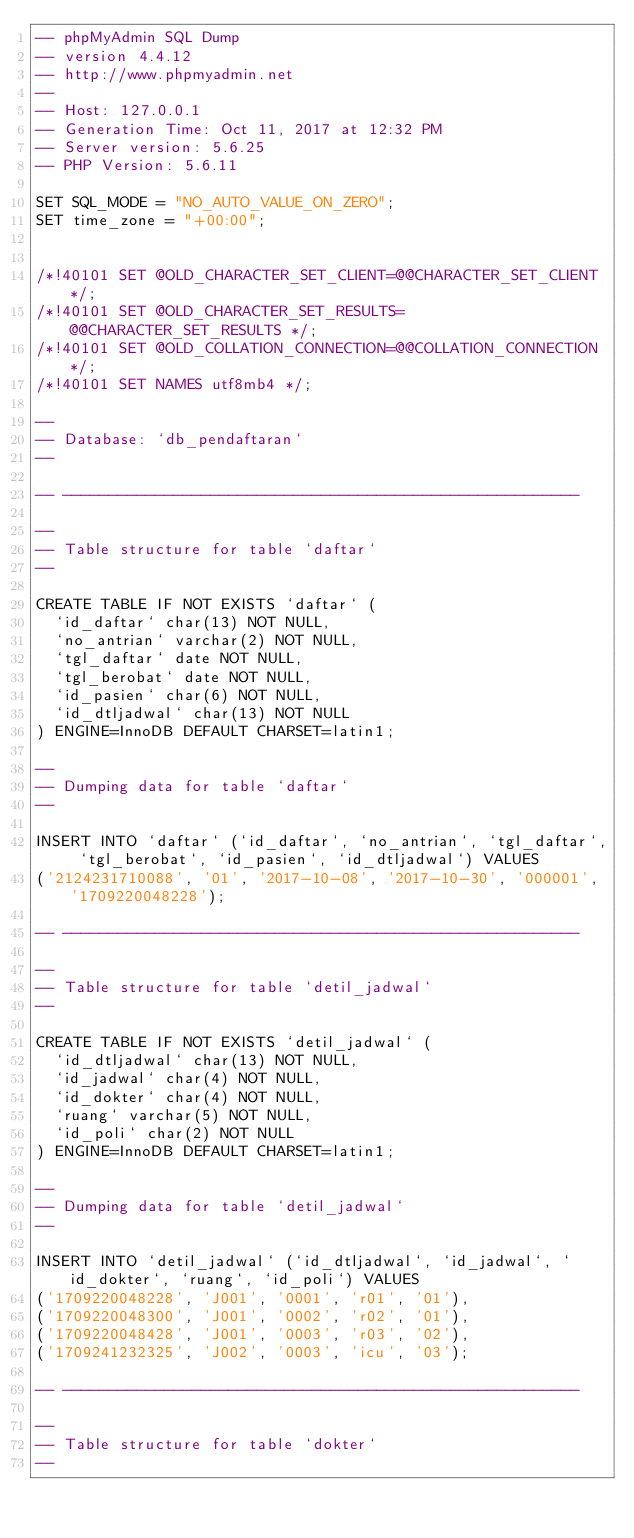<code> <loc_0><loc_0><loc_500><loc_500><_SQL_>-- phpMyAdmin SQL Dump
-- version 4.4.12
-- http://www.phpmyadmin.net
--
-- Host: 127.0.0.1
-- Generation Time: Oct 11, 2017 at 12:32 PM
-- Server version: 5.6.25
-- PHP Version: 5.6.11

SET SQL_MODE = "NO_AUTO_VALUE_ON_ZERO";
SET time_zone = "+00:00";


/*!40101 SET @OLD_CHARACTER_SET_CLIENT=@@CHARACTER_SET_CLIENT */;
/*!40101 SET @OLD_CHARACTER_SET_RESULTS=@@CHARACTER_SET_RESULTS */;
/*!40101 SET @OLD_COLLATION_CONNECTION=@@COLLATION_CONNECTION */;
/*!40101 SET NAMES utf8mb4 */;

--
-- Database: `db_pendaftaran`
--

-- --------------------------------------------------------

--
-- Table structure for table `daftar`
--

CREATE TABLE IF NOT EXISTS `daftar` (
  `id_daftar` char(13) NOT NULL,
  `no_antrian` varchar(2) NOT NULL,
  `tgl_daftar` date NOT NULL,
  `tgl_berobat` date NOT NULL,
  `id_pasien` char(6) NOT NULL,
  `id_dtljadwal` char(13) NOT NULL
) ENGINE=InnoDB DEFAULT CHARSET=latin1;

--
-- Dumping data for table `daftar`
--

INSERT INTO `daftar` (`id_daftar`, `no_antrian`, `tgl_daftar`, `tgl_berobat`, `id_pasien`, `id_dtljadwal`) VALUES
('2124231710088', '01', '2017-10-08', '2017-10-30', '000001', '1709220048228');

-- --------------------------------------------------------

--
-- Table structure for table `detil_jadwal`
--

CREATE TABLE IF NOT EXISTS `detil_jadwal` (
  `id_dtljadwal` char(13) NOT NULL,
  `id_jadwal` char(4) NOT NULL,
  `id_dokter` char(4) NOT NULL,
  `ruang` varchar(5) NOT NULL,
  `id_poli` char(2) NOT NULL
) ENGINE=InnoDB DEFAULT CHARSET=latin1;

--
-- Dumping data for table `detil_jadwal`
--

INSERT INTO `detil_jadwal` (`id_dtljadwal`, `id_jadwal`, `id_dokter`, `ruang`, `id_poli`) VALUES
('1709220048228', 'J001', '0001', 'r01', '01'),
('1709220048300', 'J001', '0002', 'r02', '01'),
('1709220048428', 'J001', '0003', 'r03', '02'),
('1709241232325', 'J002', '0003', 'icu', '03');

-- --------------------------------------------------------

--
-- Table structure for table `dokter`
--
</code> 